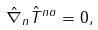Convert formula to latex. <formula><loc_0><loc_0><loc_500><loc_500>\hat { \nabla } _ { n } \hat { T } ^ { n a } = 0 ,</formula> 